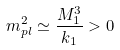<formula> <loc_0><loc_0><loc_500><loc_500>m _ { p l } ^ { 2 } \simeq \frac { M _ { 1 } ^ { 3 } } { k _ { 1 } } > 0</formula> 